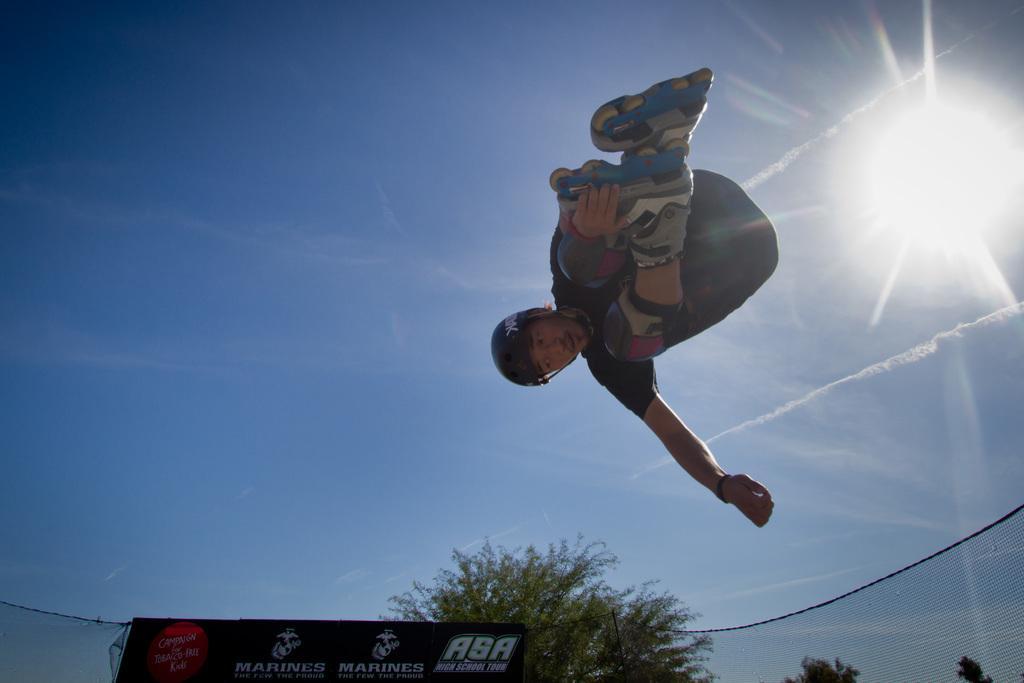Please provide a concise description of this image. In this picture we can see a person jumping in the air. There is a banner and a few trees in the background. We can see the sun in the sky. 